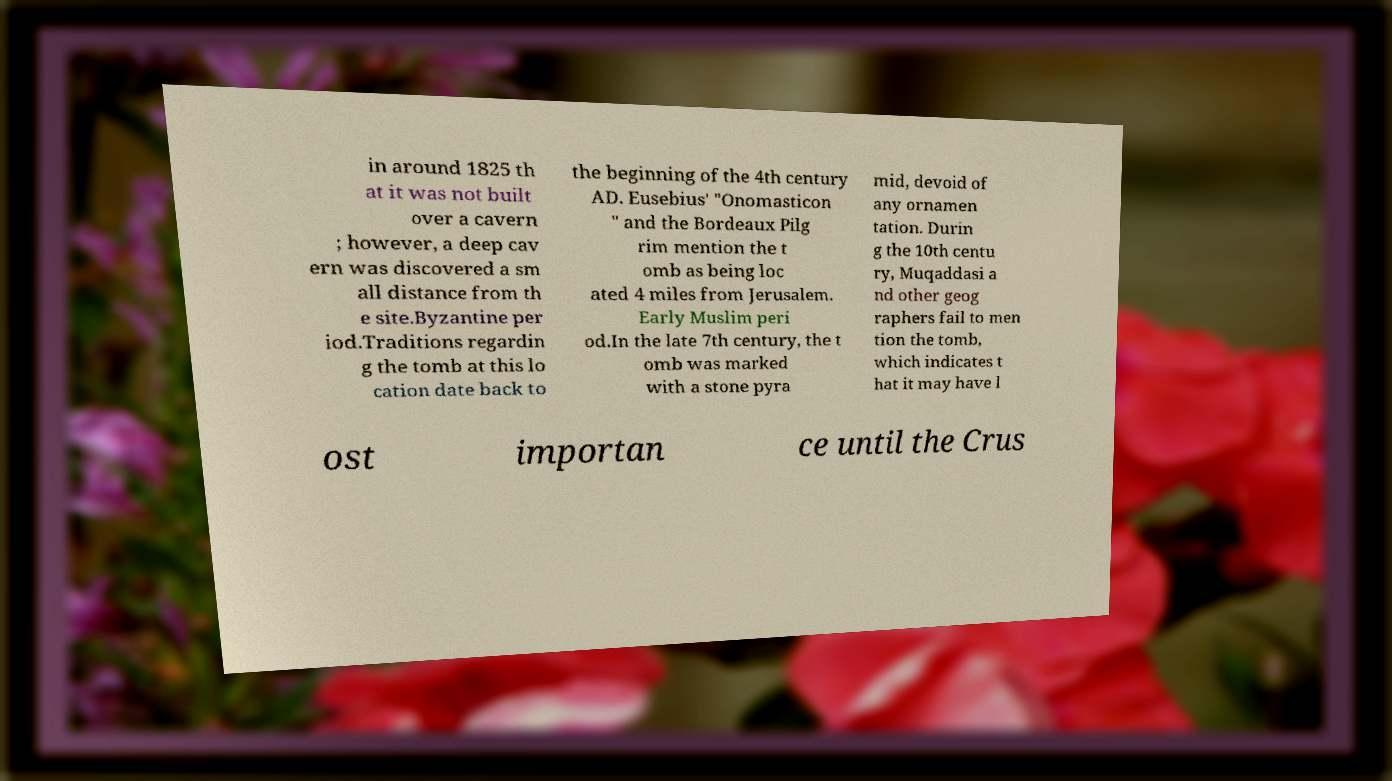Can you accurately transcribe the text from the provided image for me? in around 1825 th at it was not built over a cavern ; however, a deep cav ern was discovered a sm all distance from th e site.Byzantine per iod.Traditions regardin g the tomb at this lo cation date back to the beginning of the 4th century AD. Eusebius' "Onomasticon " and the Bordeaux Pilg rim mention the t omb as being loc ated 4 miles from Jerusalem. Early Muslim peri od.In the late 7th century, the t omb was marked with a stone pyra mid, devoid of any ornamen tation. Durin g the 10th centu ry, Muqaddasi a nd other geog raphers fail to men tion the tomb, which indicates t hat it may have l ost importan ce until the Crus 